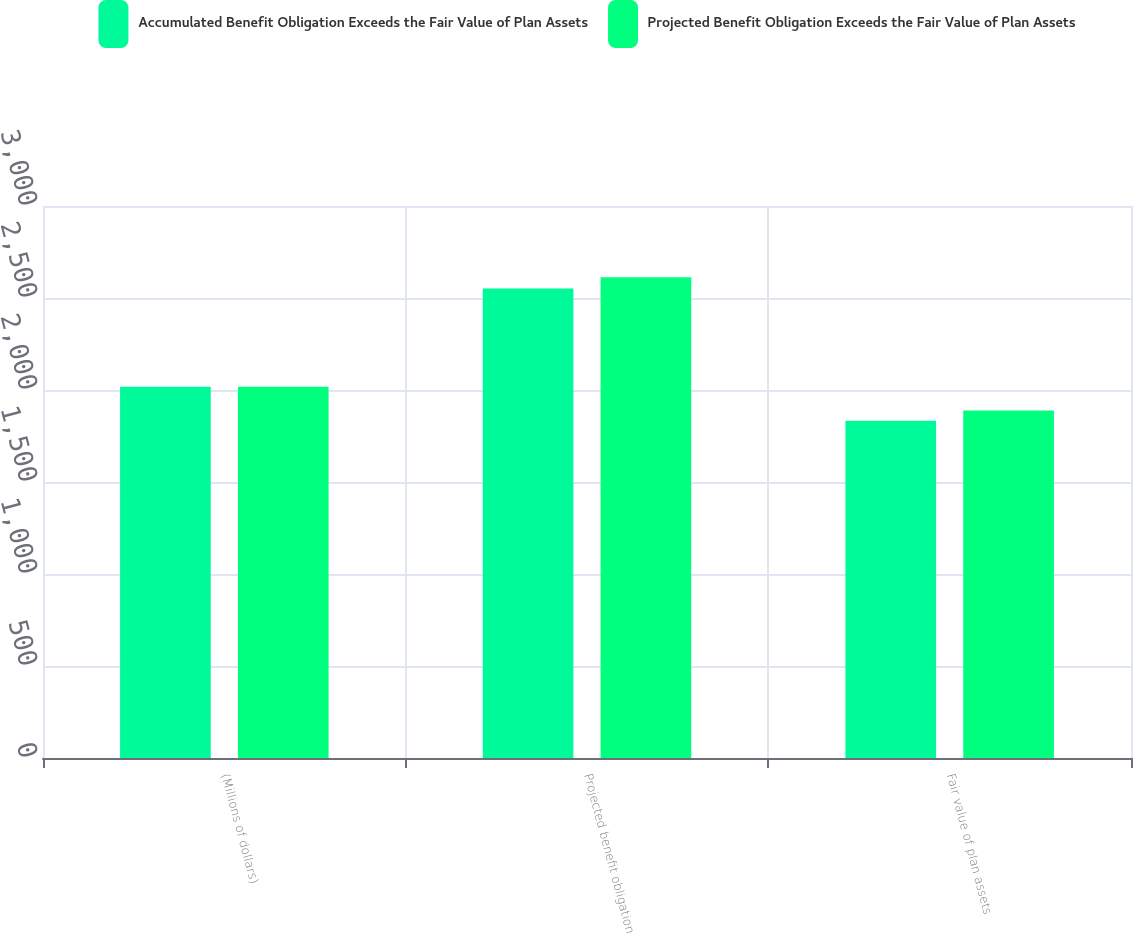Convert chart to OTSL. <chart><loc_0><loc_0><loc_500><loc_500><stacked_bar_chart><ecel><fcel>(Millions of dollars)<fcel>Projected benefit obligation<fcel>Fair value of plan assets<nl><fcel>Accumulated Benefit Obligation Exceeds the Fair Value of Plan Assets<fcel>2017<fcel>2551<fcel>1833<nl><fcel>Projected Benefit Obligation Exceeds the Fair Value of Plan Assets<fcel>2017<fcel>2613<fcel>1889<nl></chart> 